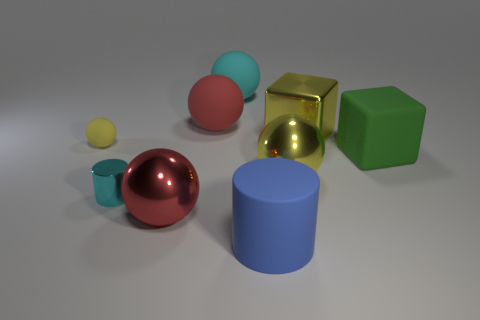How many yellow shiny blocks have the same size as the red metallic sphere?
Ensure brevity in your answer.  1. There is a yellow thing left of the large red rubber thing; how many shiny cubes are in front of it?
Make the answer very short. 0. Do the cylinder on the left side of the large blue cylinder and the big yellow sphere have the same material?
Offer a very short reply. Yes. Are the small thing in front of the big green block and the large red sphere that is behind the large green cube made of the same material?
Your answer should be very brief. No. Is the number of big shiny objects that are behind the small cyan metal cylinder greater than the number of gray matte objects?
Your response must be concise. Yes. The small object behind the yellow ball that is in front of the green matte cube is what color?
Offer a very short reply. Yellow. There is a cyan thing that is the same size as the green cube; what shape is it?
Provide a succinct answer. Sphere. What is the shape of the big thing that is the same color as the tiny cylinder?
Give a very brief answer. Sphere. Are there the same number of rubber objects that are right of the tiny shiny cylinder and large spheres?
Your answer should be very brief. Yes. The cyan object that is right of the red ball behind the yellow ball that is to the left of the large red metallic thing is made of what material?
Make the answer very short. Rubber. 